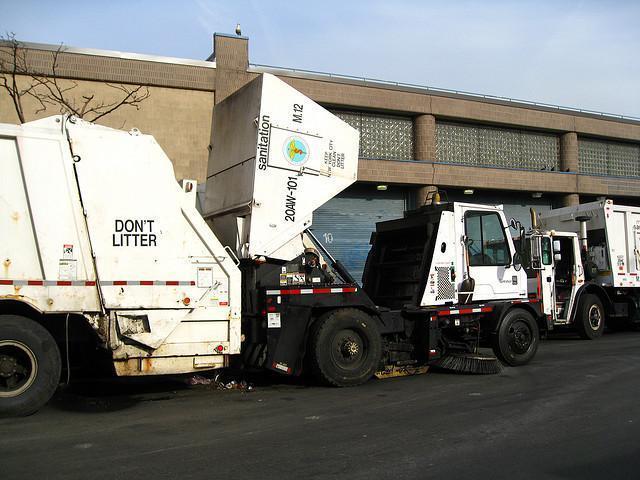How many wheels are seen?
Give a very brief answer. 4. How many trucks are in the photo?
Give a very brief answer. 2. How many people carry bags?
Give a very brief answer. 0. 